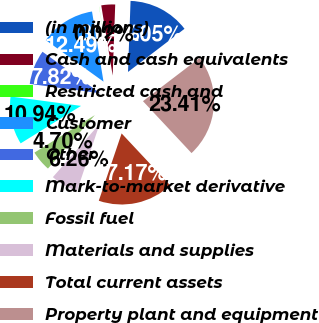<chart> <loc_0><loc_0><loc_500><loc_500><pie_chart><fcel>(in millions)<fcel>Cash and cash equivalents<fcel>Restricted cash and<fcel>Customer<fcel>Other<fcel>Mark-to-market derivative<fcel>Fossil fuel<fcel>Materials and supplies<fcel>Total current assets<fcel>Property plant and equipment<nl><fcel>14.05%<fcel>3.14%<fcel>0.02%<fcel>12.49%<fcel>7.82%<fcel>10.94%<fcel>4.7%<fcel>6.26%<fcel>17.17%<fcel>23.41%<nl></chart> 